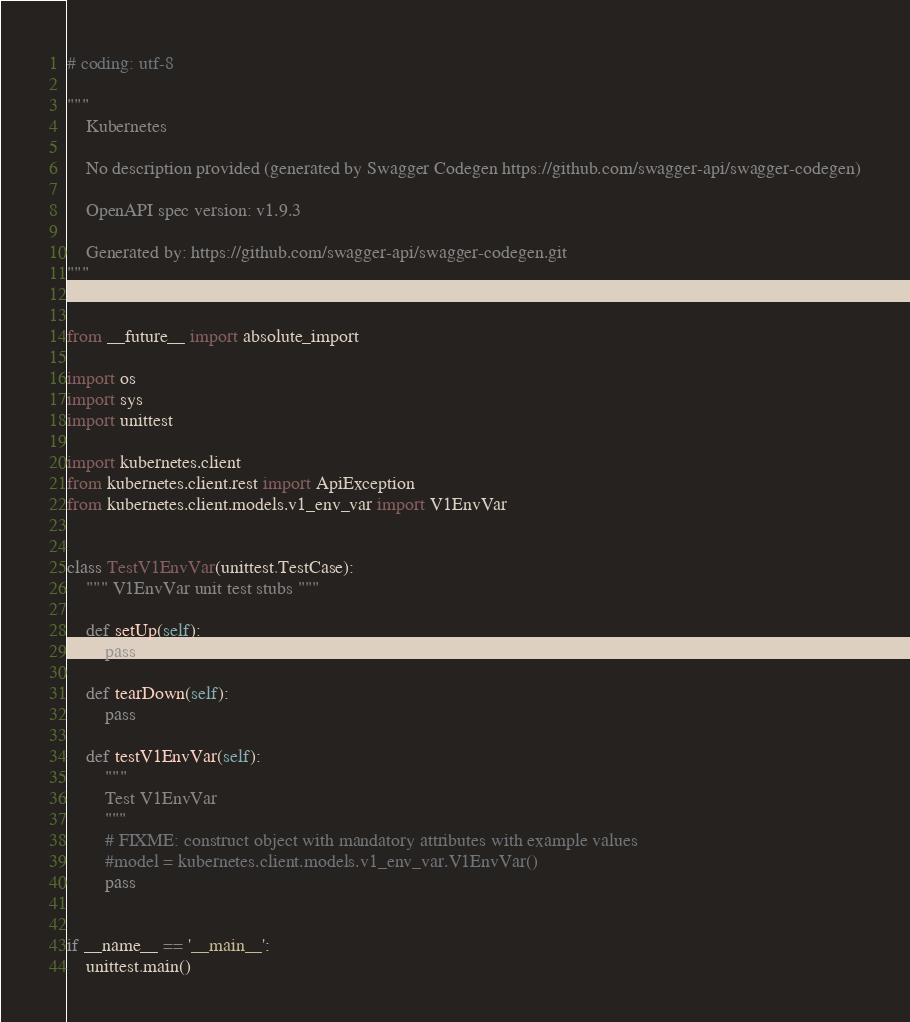Convert code to text. <code><loc_0><loc_0><loc_500><loc_500><_Python_># coding: utf-8

"""
    Kubernetes

    No description provided (generated by Swagger Codegen https://github.com/swagger-api/swagger-codegen)

    OpenAPI spec version: v1.9.3
    
    Generated by: https://github.com/swagger-api/swagger-codegen.git
"""


from __future__ import absolute_import

import os
import sys
import unittest

import kubernetes.client
from kubernetes.client.rest import ApiException
from kubernetes.client.models.v1_env_var import V1EnvVar


class TestV1EnvVar(unittest.TestCase):
    """ V1EnvVar unit test stubs """

    def setUp(self):
        pass

    def tearDown(self):
        pass

    def testV1EnvVar(self):
        """
        Test V1EnvVar
        """
        # FIXME: construct object with mandatory attributes with example values
        #model = kubernetes.client.models.v1_env_var.V1EnvVar()
        pass


if __name__ == '__main__':
    unittest.main()
</code> 